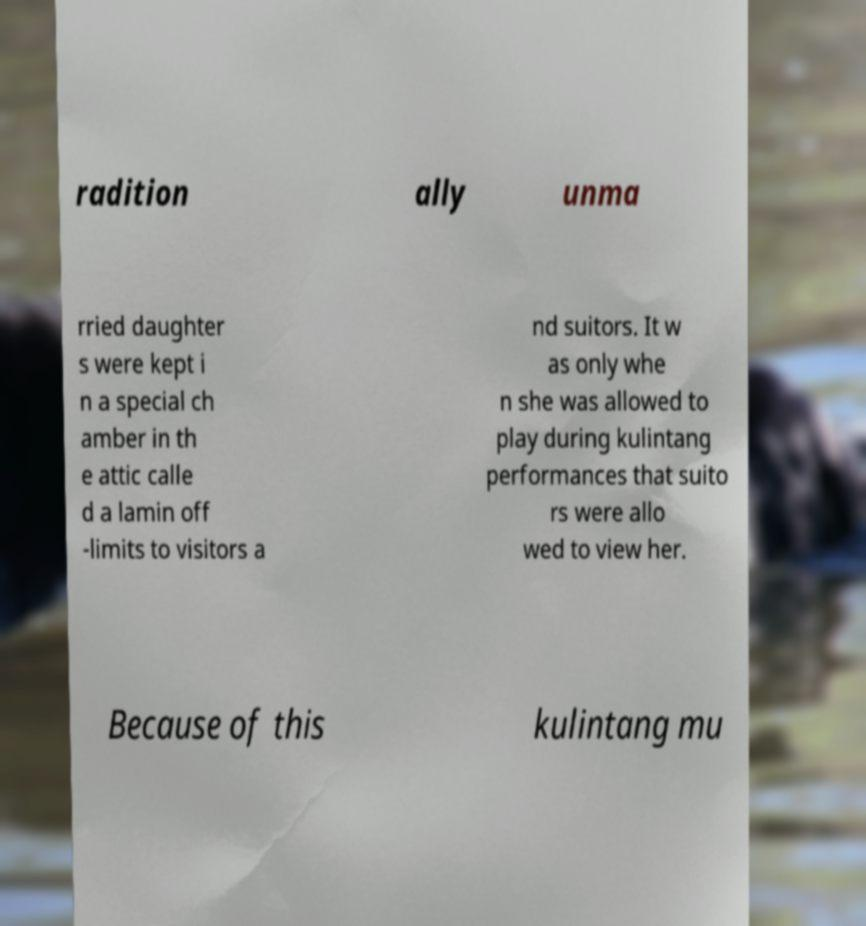For documentation purposes, I need the text within this image transcribed. Could you provide that? radition ally unma rried daughter s were kept i n a special ch amber in th e attic calle d a lamin off -limits to visitors a nd suitors. It w as only whe n she was allowed to play during kulintang performances that suito rs were allo wed to view her. Because of this kulintang mu 